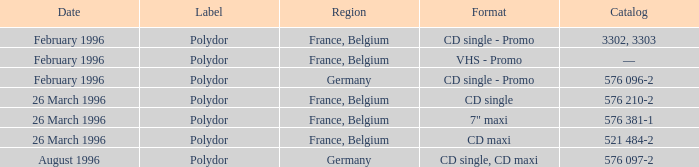Indicate the territory for catalog of 576 096-2 Germany. 